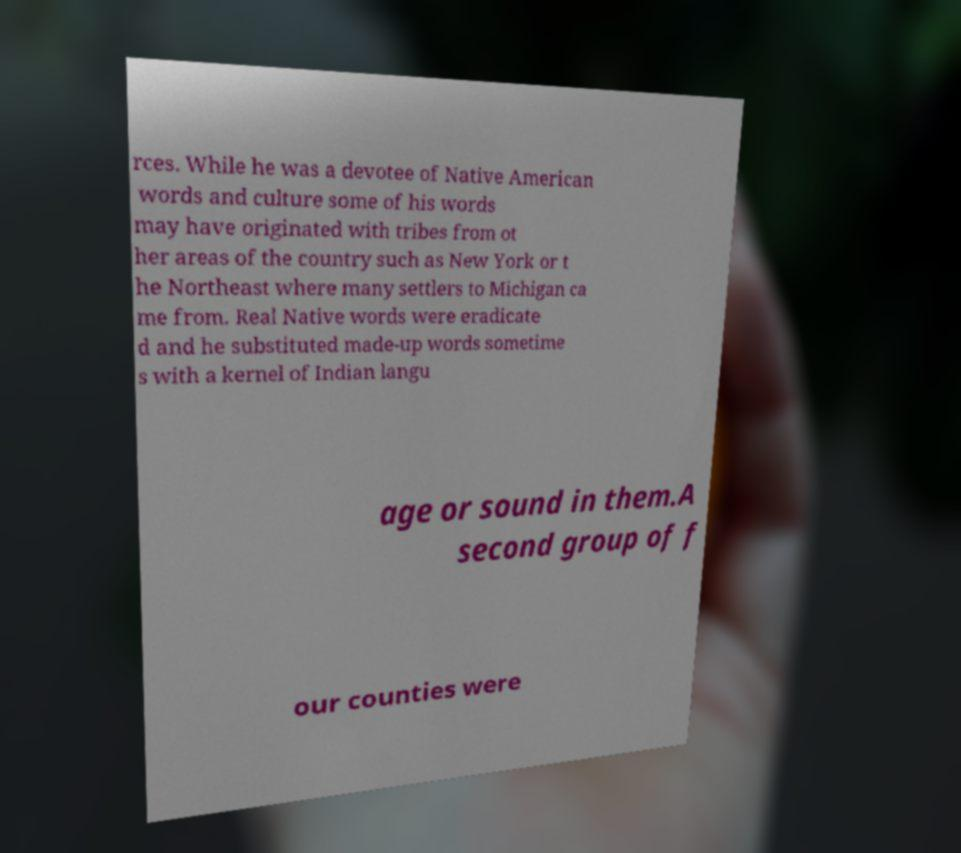Can you read and provide the text displayed in the image?This photo seems to have some interesting text. Can you extract and type it out for me? rces. While he was a devotee of Native American words and culture some of his words may have originated with tribes from ot her areas of the country such as New York or t he Northeast where many settlers to Michigan ca me from. Real Native words were eradicate d and he substituted made-up words sometime s with a kernel of Indian langu age or sound in them.A second group of f our counties were 